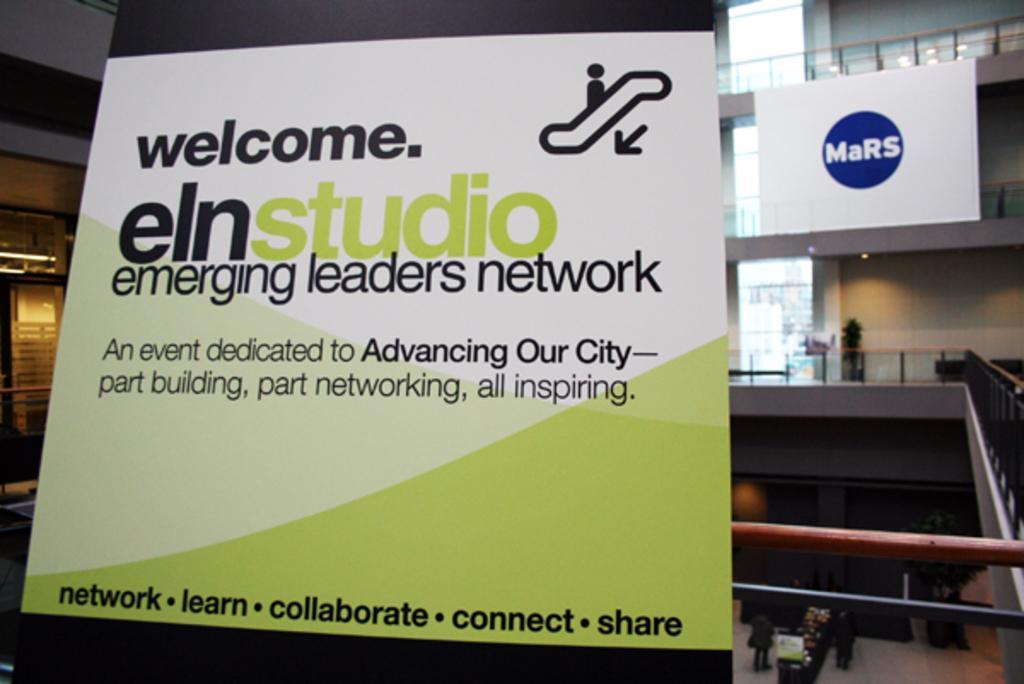In one or two sentences, can you explain what this image depicts? In this picture, This building looks like a shopping complex and there is a flex and there is something written on it and also i can see two people standing on the floor after that a light , a artificial tree and few more lights and windows which is covered with glass. 